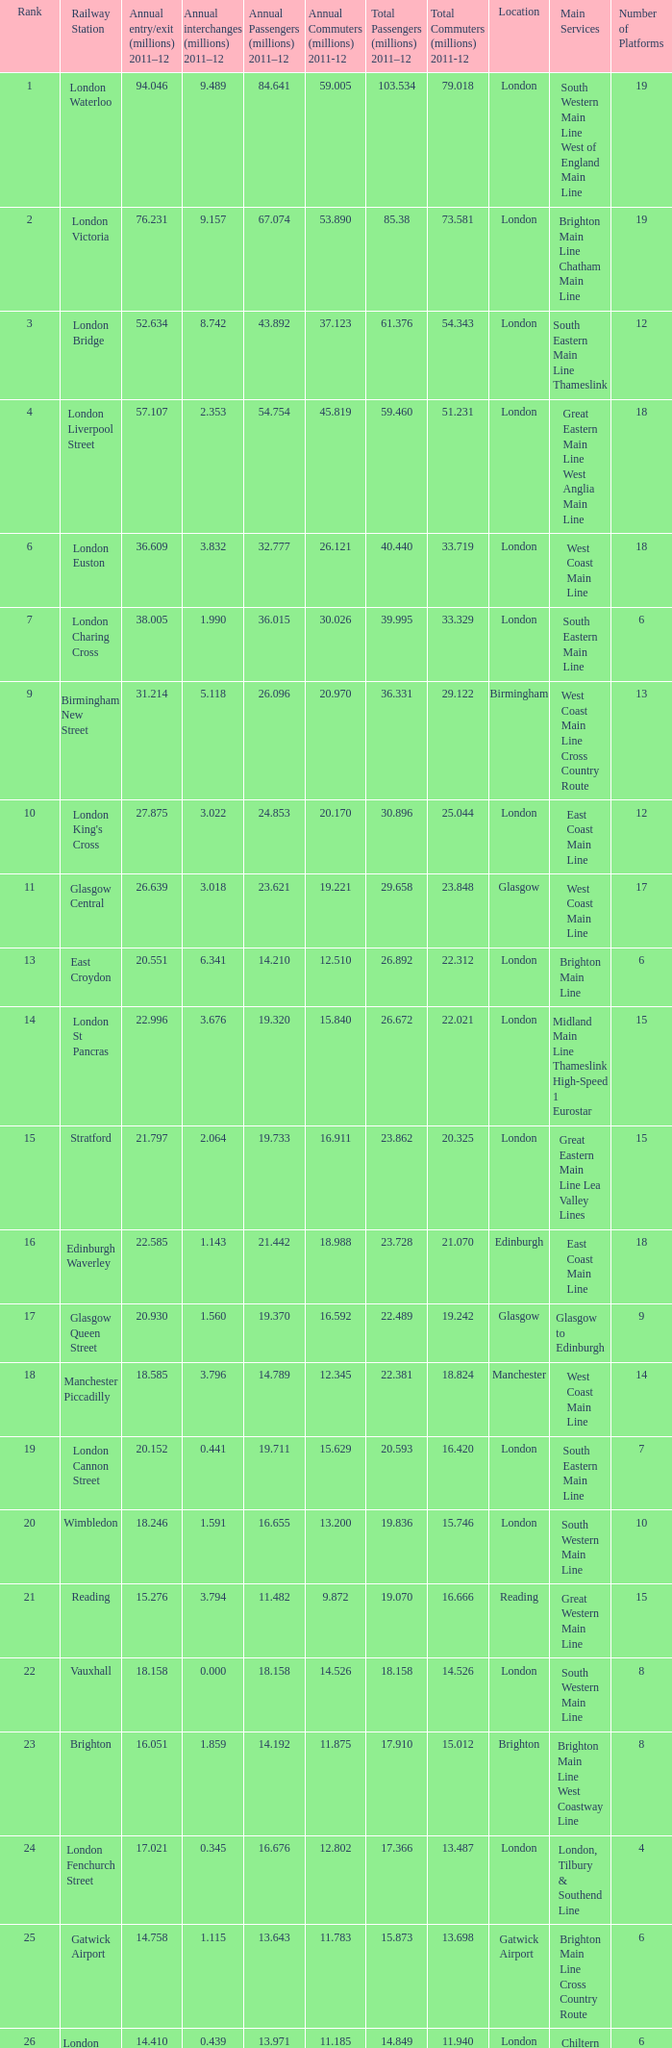What is the main service for the station with 14.849 million passengers 2011-12?  Chiltern Main Line. Could you parse the entire table? {'header': ['Rank', 'Railway Station', 'Annual entry/exit (millions) 2011–12', 'Annual interchanges (millions) 2011–12', 'Annual Passengers (millions) 2011–12', 'Annual Commuters (millions) 2011-12', 'Total Passengers (millions) 2011–12', 'Total Commuters (millions) 2011-12', 'Location', 'Main Services', 'Number of Platforms'], 'rows': [['1', 'London Waterloo', '94.046', '9.489', '84.641', '59.005', '103.534', '79.018', 'London', 'South Western Main Line West of England Main Line', '19'], ['2', 'London Victoria', '76.231', '9.157', '67.074', '53.890', '85.38', '73.581', 'London', 'Brighton Main Line Chatham Main Line', '19'], ['3', 'London Bridge', '52.634', '8.742', '43.892', '37.123', '61.376', '54.343', 'London', 'South Eastern Main Line Thameslink', '12'], ['4', 'London Liverpool Street', '57.107', '2.353', '54.754', '45.819', '59.460', '51.231', 'London', 'Great Eastern Main Line West Anglia Main Line', '18'], ['6', 'London Euston', '36.609', '3.832', '32.777', '26.121', '40.440', '33.719', 'London', 'West Coast Main Line', '18'], ['7', 'London Charing Cross', '38.005', '1.990', '36.015', '30.026', '39.995', '33.329', 'London', 'South Eastern Main Line', '6'], ['9', 'Birmingham New Street', '31.214', '5.118', '26.096', '20.970', '36.331', '29.122', 'Birmingham', 'West Coast Main Line Cross Country Route', '13'], ['10', "London King's Cross", '27.875', '3.022', '24.853', '20.170', '30.896', '25.044', 'London', 'East Coast Main Line', '12'], ['11', 'Glasgow Central', '26.639', '3.018', '23.621', '19.221', '29.658', '23.848', 'Glasgow', 'West Coast Main Line', '17'], ['13', 'East Croydon', '20.551', '6.341', '14.210', '12.510', '26.892', '22.312', 'London', 'Brighton Main Line', '6'], ['14', 'London St Pancras', '22.996', '3.676', '19.320', '15.840', '26.672', '22.021', 'London', 'Midland Main Line Thameslink High-Speed 1 Eurostar', '15'], ['15', 'Stratford', '21.797', '2.064', '19.733', '16.911', '23.862', '20.325', 'London', 'Great Eastern Main Line Lea Valley Lines', '15'], ['16', 'Edinburgh Waverley', '22.585', '1.143', '21.442', '18.988', '23.728', '21.070', 'Edinburgh', 'East Coast Main Line', '18'], ['17', 'Glasgow Queen Street', '20.930', '1.560', '19.370', '16.592', '22.489', '19.242', 'Glasgow', 'Glasgow to Edinburgh', '9'], ['18', 'Manchester Piccadilly', '18.585', '3.796', '14.789', '12.345', '22.381', '18.824', 'Manchester', 'West Coast Main Line', '14'], ['19', 'London Cannon Street', '20.152', '0.441', '19.711', '15.629', '20.593', '16.420', 'London', 'South Eastern Main Line', '7'], ['20', 'Wimbledon', '18.246', '1.591', '16.655', '13.200', '19.836', '15.746', 'London', 'South Western Main Line', '10'], ['21', 'Reading', '15.276', '3.794', '11.482', '9.872', '19.070', '16.666', 'Reading', 'Great Western Main Line', '15'], ['22', 'Vauxhall', '18.158', '0.000', '18.158', '14.526', '18.158', '14.526', 'London', 'South Western Main Line', '8'], ['23', 'Brighton', '16.051', '1.859', '14.192', '11.875', '17.910', '15.012', 'Brighton', 'Brighton Main Line West Coastway Line', '8'], ['24', 'London Fenchurch Street', '17.021', '0.345', '16.676', '12.802', '17.366', '13.487', 'London', 'London, Tilbury & Southend Line', '4'], ['25', 'Gatwick Airport', '14.758', '1.115', '13.643', '11.783', '15.873', '13.698', 'Gatwick Airport', 'Brighton Main Line Cross Country Route', '6'], ['26', 'London Marylebone', '14.410', '0.439', '13.971', '11.185', '14.849', '11.940', 'London', 'Chiltern Main Line', '6'], ['27', 'Liverpool Central', '14.209', '0.412', '13.797', '12.187', '14.622', '12.911', 'Liverpool', 'Merseyrail services (Wirral and Northern lines)', '3'], ['28', 'Liverpool Lime Street', '13.835', '0.778', '13.057', '10.682', '14.613', '12.020', 'Liverpool', 'West Coast Main Line Liverpool to Manchester Lines', '10'], ['29', 'London Blackfriars', '12.79', '1.059', '11.731', '9.672', '13.850', '11.431', 'London', 'Thameslink', '4']]} 